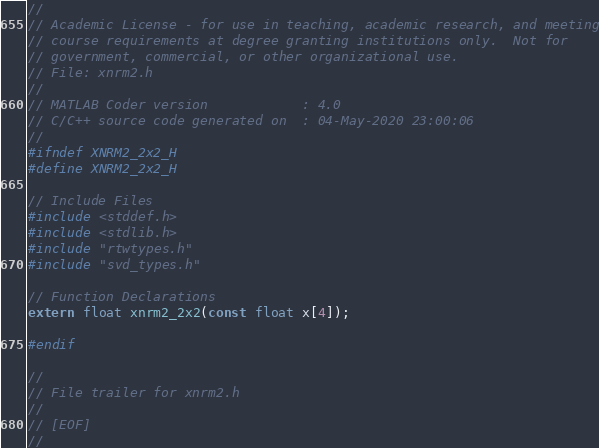<code> <loc_0><loc_0><loc_500><loc_500><_C_>//
// Academic License - for use in teaching, academic research, and meeting
// course requirements at degree granting institutions only.  Not for
// government, commercial, or other organizational use.
// File: xnrm2.h
//
// MATLAB Coder version            : 4.0
// C/C++ source code generated on  : 04-May-2020 23:00:06
//
#ifndef XNRM2_2x2_H
#define XNRM2_2x2_H

// Include Files
#include <stddef.h>
#include <stdlib.h>
#include "rtwtypes.h"
#include "svd_types.h"

// Function Declarations
extern float xnrm2_2x2(const float x[4]);

#endif

//
// File trailer for xnrm2.h
//
// [EOF]
//
</code> 